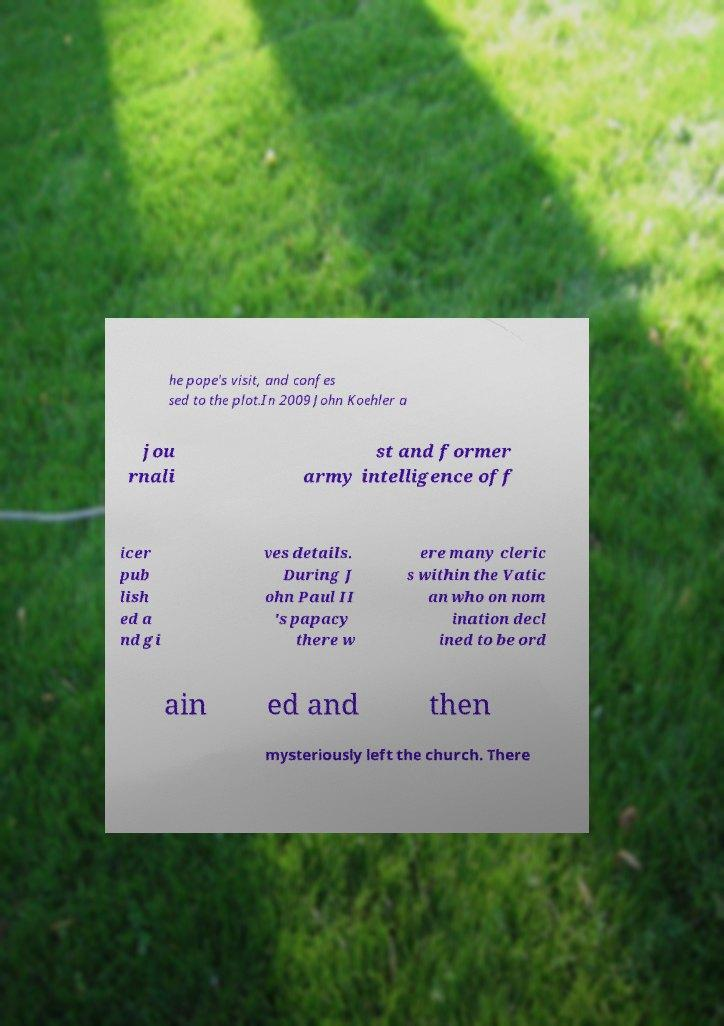For documentation purposes, I need the text within this image transcribed. Could you provide that? he pope's visit, and confes sed to the plot.In 2009 John Koehler a jou rnali st and former army intelligence off icer pub lish ed a nd gi ves details. During J ohn Paul II 's papacy there w ere many cleric s within the Vatic an who on nom ination decl ined to be ord ain ed and then mysteriously left the church. There 